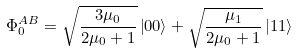<formula> <loc_0><loc_0><loc_500><loc_500>\Phi _ { 0 } ^ { A B } = \sqrt { \frac { 3 \mu _ { 0 } } { 2 \mu _ { 0 } + 1 } } \left | 0 0 \right \rangle + \sqrt { \frac { \mu _ { 1 } } { 2 \mu _ { 0 } + 1 } } \left | 1 1 \right \rangle</formula> 